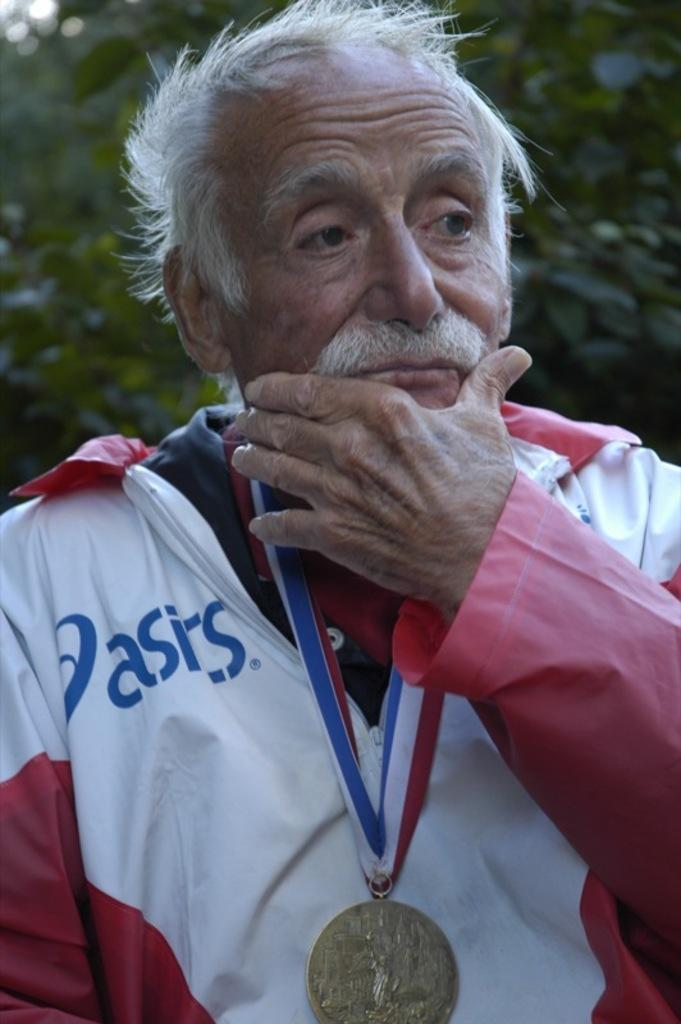Provide a one-sentence caption for the provided image. An older man with an Olympic medal is wearing an asics branded jacket. 